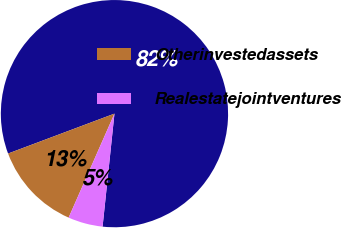Convert chart. <chart><loc_0><loc_0><loc_500><loc_500><pie_chart><ecel><fcel>Otherinvestedassets<fcel>Realestatejointventures<nl><fcel>82.38%<fcel>12.68%<fcel>4.94%<nl></chart> 